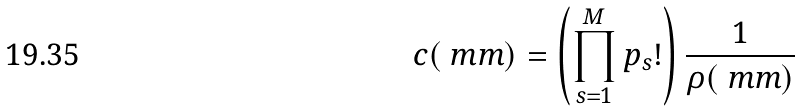Convert formula to latex. <formula><loc_0><loc_0><loc_500><loc_500>c ( \ m m ) = \left ( \prod _ { s = 1 } ^ { M } p _ { s } ! \right ) \frac { 1 } { \rho ( \ m m ) }</formula> 